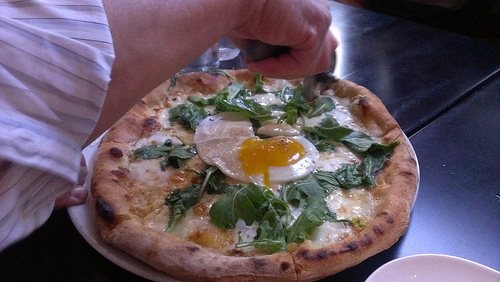Is the cheese to the left or to the right of him? The cheese is to his right. 